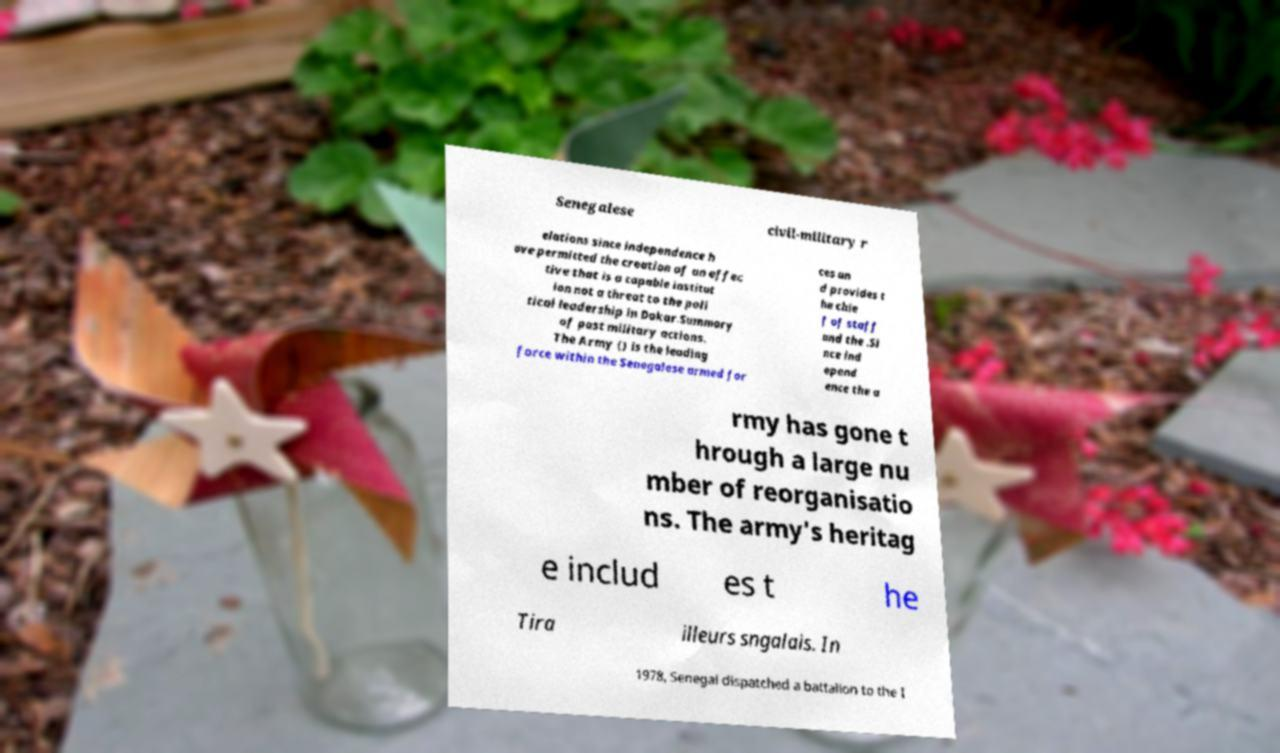Could you assist in decoding the text presented in this image and type it out clearly? Senegalese civil-military r elations since independence h ave permitted the creation of an effec tive that is a capable institut ion not a threat to the poli tical leadership in Dakar.Summary of past military actions. The Army () is the leading force within the Senegalese armed for ces an d provides t he chie f of staff and the .Si nce ind epend ence the a rmy has gone t hrough a large nu mber of reorganisatio ns. The army's heritag e includ es t he Tira illeurs sngalais. In 1978, Senegal dispatched a battalion to the I 